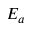Convert formula to latex. <formula><loc_0><loc_0><loc_500><loc_500>E _ { a }</formula> 